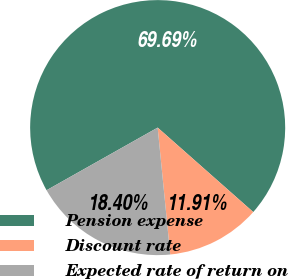Convert chart. <chart><loc_0><loc_0><loc_500><loc_500><pie_chart><fcel>Pension expense<fcel>Discount rate<fcel>Expected rate of return on<nl><fcel>69.68%<fcel>11.91%<fcel>18.4%<nl></chart> 